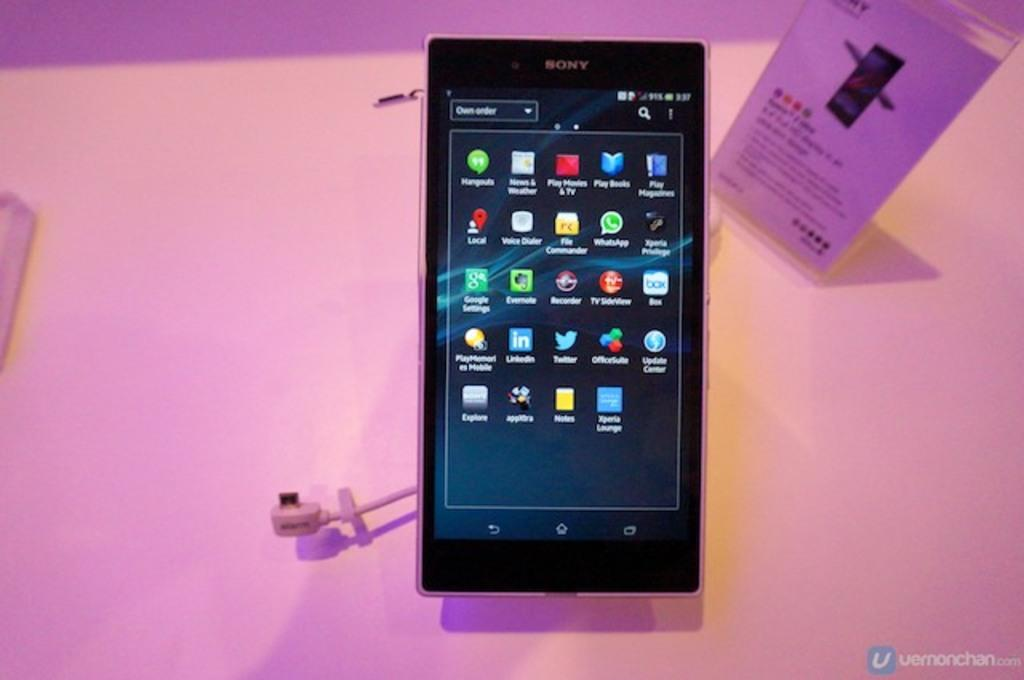<image>
Create a compact narrative representing the image presented. A Sony phone is displaying the home menu. 